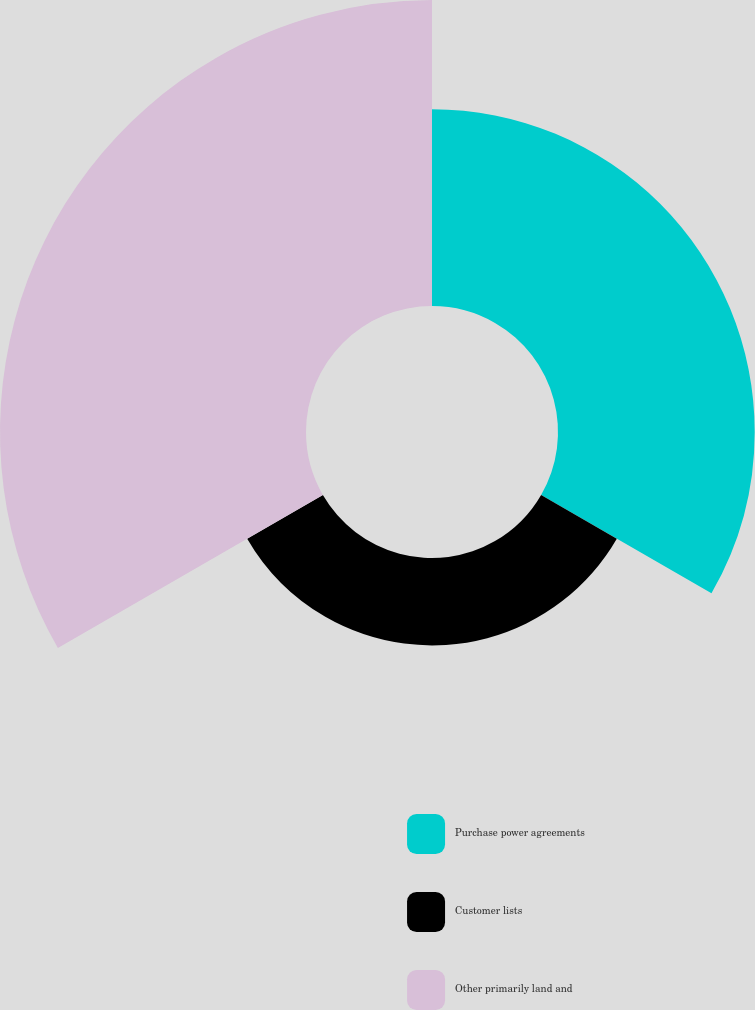Convert chart to OTSL. <chart><loc_0><loc_0><loc_500><loc_500><pie_chart><fcel>Purchase power agreements<fcel>Customer lists<fcel>Other primarily land and<nl><fcel>33.33%<fcel>14.81%<fcel>51.85%<nl></chart> 